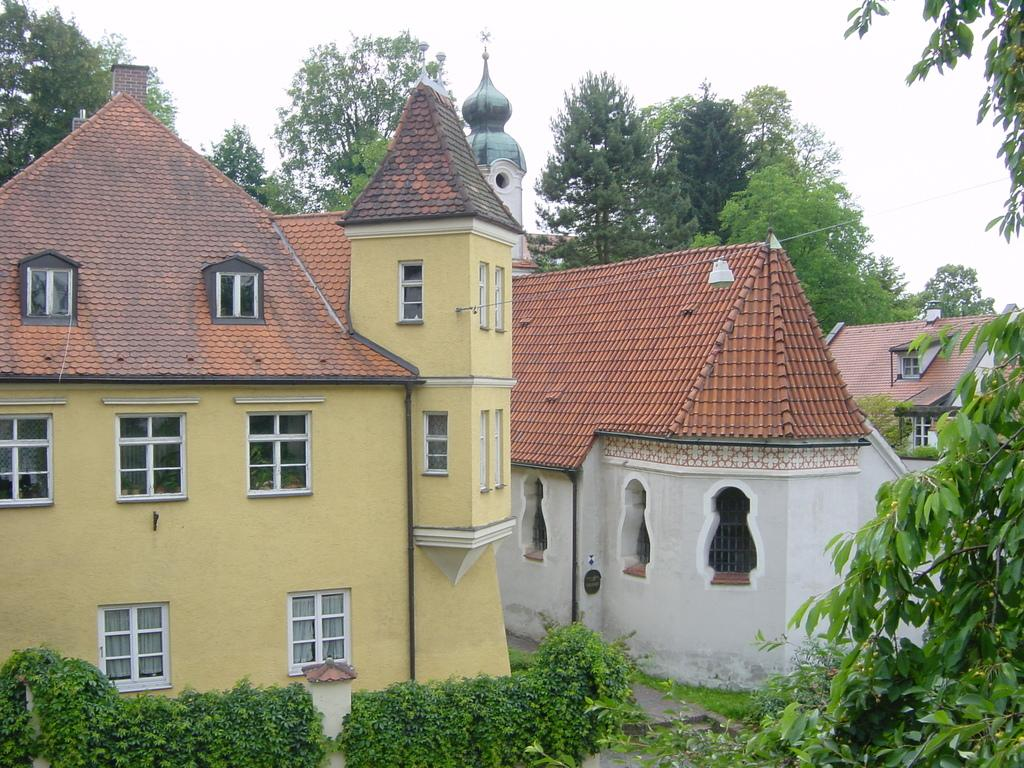What type of structures can be seen in the image? There are a few houses in the image. What type of vegetation is visible in the image? There are trees and plants in the image. What part of the natural environment is visible in the image? The ground and the sky are visible in the image. How many bears are visible in the image? There are no bears present in the image. What direction are the houses pointing in the image? The direction in which the houses are pointing cannot be determined from the image. 